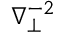Convert formula to latex. <formula><loc_0><loc_0><loc_500><loc_500>\nabla _ { \perp } ^ { - 2 }</formula> 